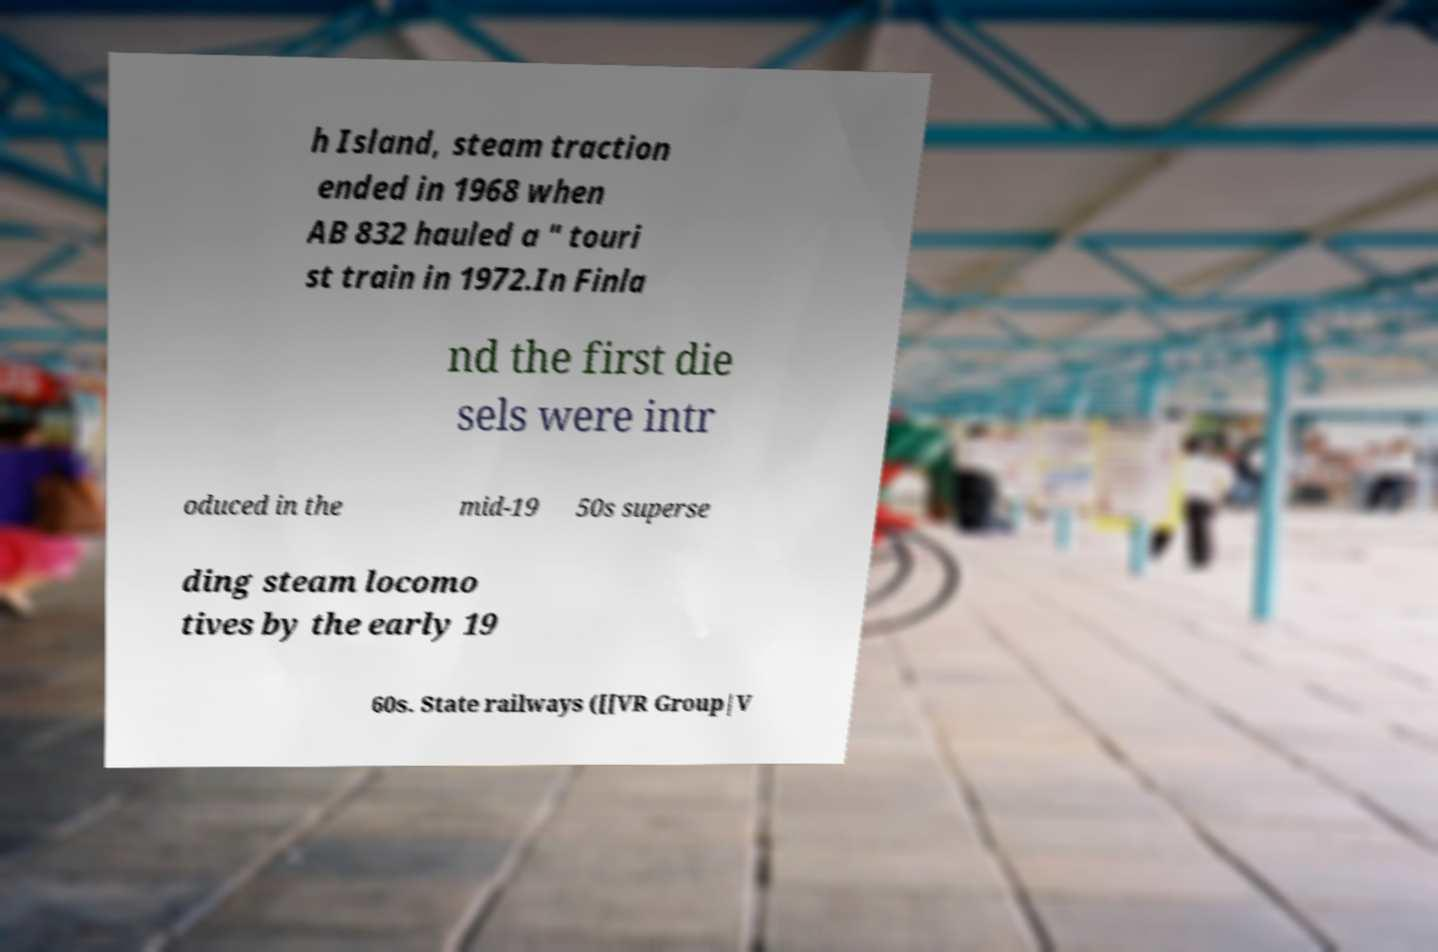Please read and relay the text visible in this image. What does it say? h Island, steam traction ended in 1968 when AB 832 hauled a " touri st train in 1972.In Finla nd the first die sels were intr oduced in the mid-19 50s superse ding steam locomo tives by the early 19 60s. State railways ([[VR Group|V 